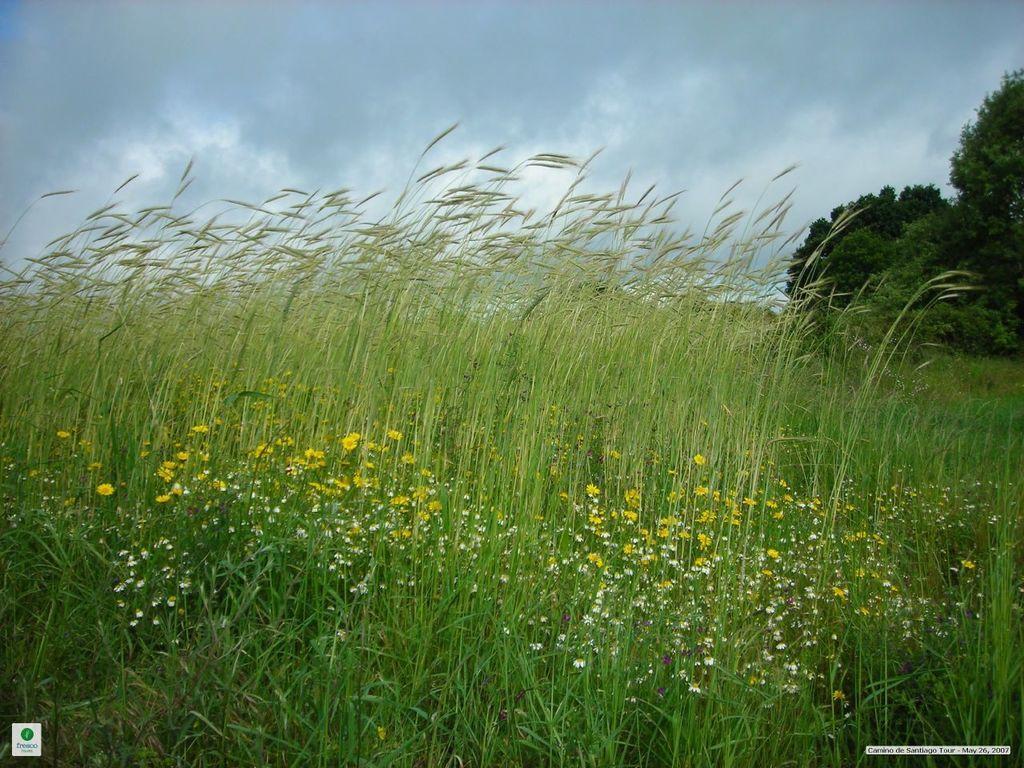Describe this image in one or two sentences. We can see grass and flowers. In the background we can see trees and sky. 